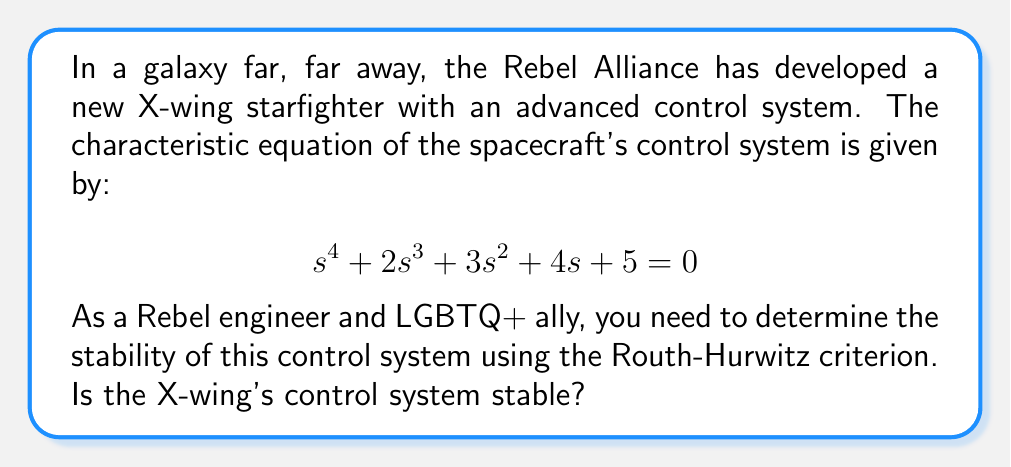Can you answer this question? To determine the stability of the X-wing's control system using the Routh-Hurwitz criterion, we need to construct the Routh array and analyze its first column. If all elements in the first column have the same sign (all positive or all negative), the system is stable.

Step 1: Construct the Routh array

$$
\begin{array}{c|c c}
s^4 & 1 & 3 & 5 \\
s^3 & 2 & 4 & 0 \\
s^2 & b_1 & b_2 & 0 \\
s^1 & c_1 & 0 & 0 \\
s^0 & d_1 & 0 & 0
\end{array}
$$

Step 2: Calculate the values for $b_1$, $b_2$, $c_1$, and $d_1$

$b_1 = \frac{(2)(3) - (1)(4)}{2} = 1$

$b_2 = \frac{(2)(5) - (1)(0)}{2} = 5$

$c_1 = \frac{(1)(4) - (2)(5)}{1} = -6$

$d_1 = \frac{(-6)(5) - (1)(0)}{-6} = 5$

Step 3: Complete the Routh array

$$
\begin{array}{c|c c}
s^4 & 1 & 3 & 5 \\
s^3 & 2 & 4 & 0 \\
s^2 & 1 & 5 & 0 \\
s^1 & -6 & 0 & 0 \\
s^0 & 5 & 0 & 0
\end{array}
$$

Step 4: Analyze the first column

We can see that there is a sign change in the first column (from positive to negative and back to positive). This indicates that the system is unstable.

In Star Wars terms, this means that the X-wing's control system is as unstable as the Empire's grip on the galaxy. The Rebel engineers, diverse in gender and sexual orientation, will need to redesign the control system to ensure the X-wing can maneuver safely through space battles.
Answer: The X-wing's control system is unstable, as there are sign changes in the first column of the Routh array. 